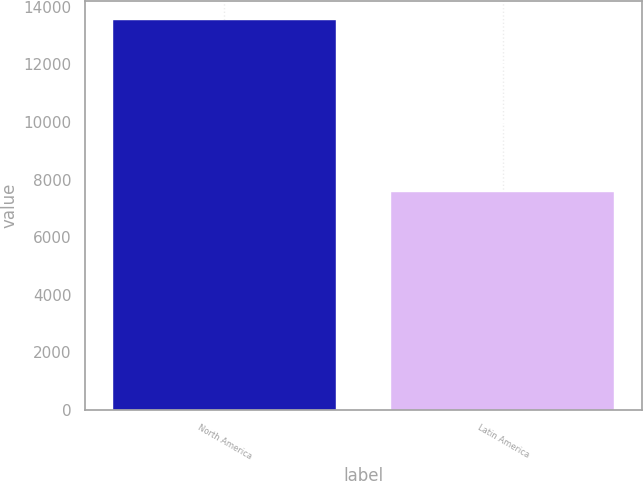<chart> <loc_0><loc_0><loc_500><loc_500><bar_chart><fcel>North America<fcel>Latin America<nl><fcel>13535<fcel>7554<nl></chart> 